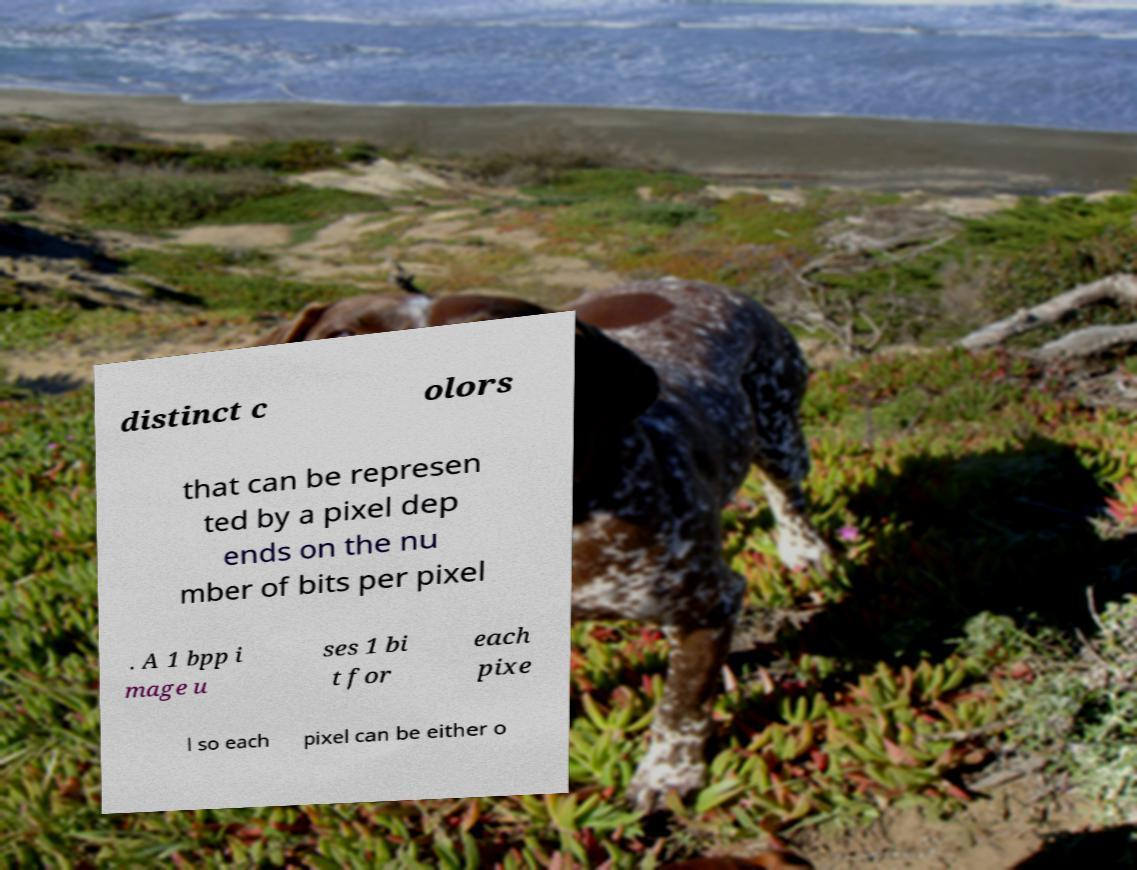Could you assist in decoding the text presented in this image and type it out clearly? distinct c olors that can be represen ted by a pixel dep ends on the nu mber of bits per pixel . A 1 bpp i mage u ses 1 bi t for each pixe l so each pixel can be either o 